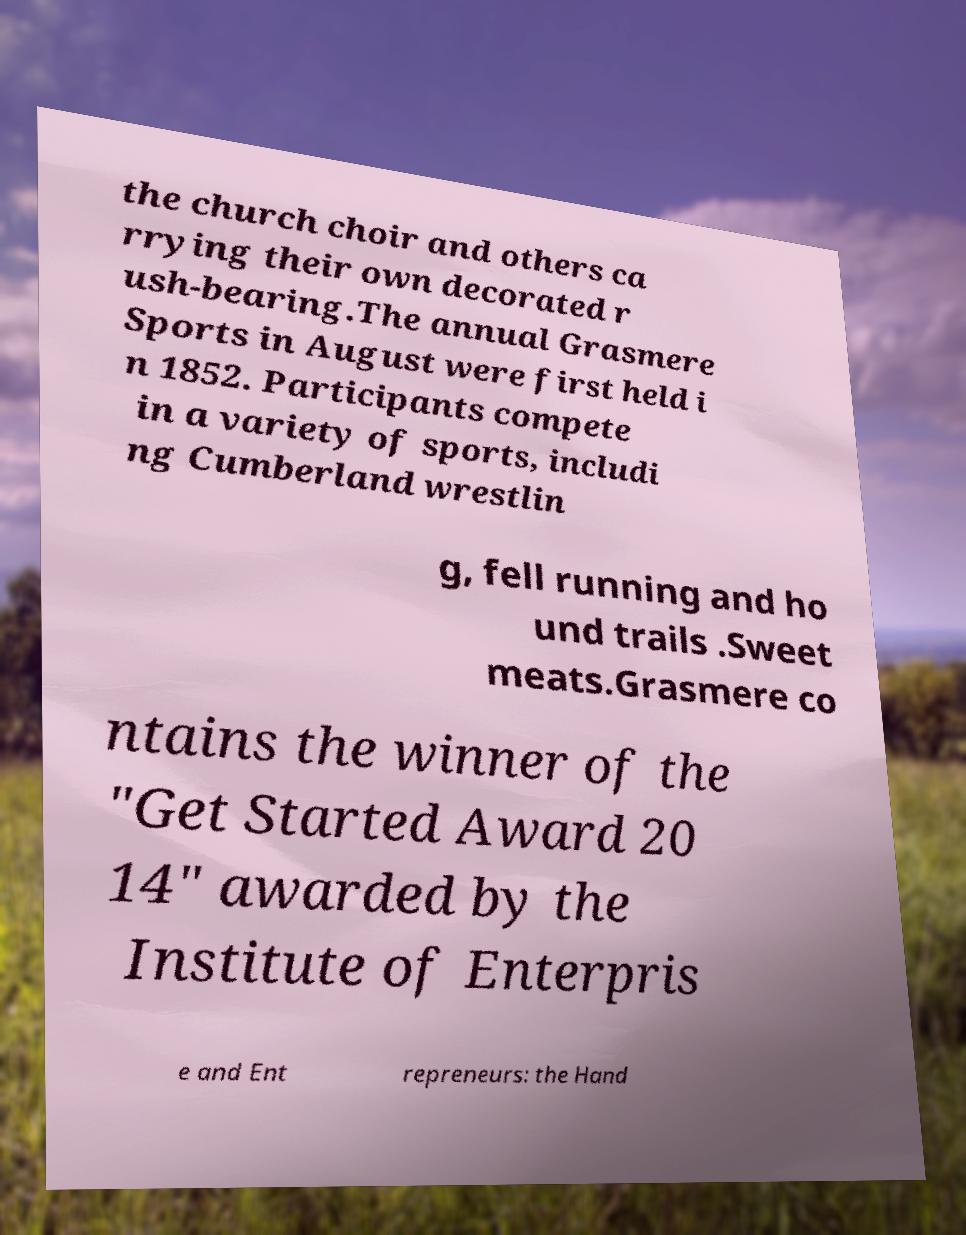Can you read and provide the text displayed in the image?This photo seems to have some interesting text. Can you extract and type it out for me? the church choir and others ca rrying their own decorated r ush-bearing.The annual Grasmere Sports in August were first held i n 1852. Participants compete in a variety of sports, includi ng Cumberland wrestlin g, fell running and ho und trails .Sweet meats.Grasmere co ntains the winner of the "Get Started Award 20 14" awarded by the Institute of Enterpris e and Ent repreneurs: the Hand 